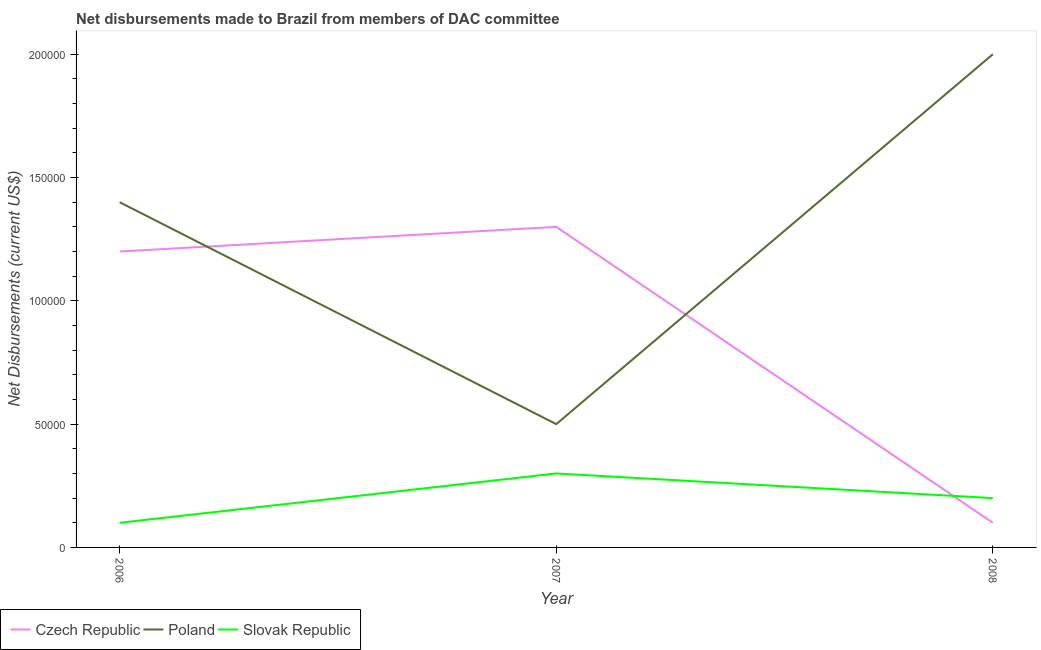Is the number of lines equal to the number of legend labels?
Make the answer very short. Yes. What is the net disbursements made by slovak republic in 2006?
Provide a succinct answer. 10000. Across all years, what is the maximum net disbursements made by poland?
Your answer should be very brief. 2.00e+05. Across all years, what is the minimum net disbursements made by poland?
Your answer should be compact. 5.00e+04. What is the total net disbursements made by czech republic in the graph?
Your response must be concise. 2.60e+05. What is the difference between the net disbursements made by slovak republic in 2006 and that in 2007?
Your answer should be compact. -2.00e+04. What is the difference between the net disbursements made by poland in 2008 and the net disbursements made by czech republic in 2007?
Provide a succinct answer. 7.00e+04. What is the average net disbursements made by czech republic per year?
Provide a succinct answer. 8.67e+04. In the year 2008, what is the difference between the net disbursements made by czech republic and net disbursements made by poland?
Provide a short and direct response. -1.90e+05. In how many years, is the net disbursements made by czech republic greater than 20000 US$?
Give a very brief answer. 2. Is the net disbursements made by poland in 2006 less than that in 2007?
Keep it short and to the point. No. What is the difference between the highest and the lowest net disbursements made by czech republic?
Your answer should be very brief. 1.20e+05. In how many years, is the net disbursements made by slovak republic greater than the average net disbursements made by slovak republic taken over all years?
Give a very brief answer. 1. Is the sum of the net disbursements made by poland in 2007 and 2008 greater than the maximum net disbursements made by slovak republic across all years?
Your answer should be compact. Yes. Is it the case that in every year, the sum of the net disbursements made by czech republic and net disbursements made by poland is greater than the net disbursements made by slovak republic?
Keep it short and to the point. Yes. How many lines are there?
Your response must be concise. 3. What is the difference between two consecutive major ticks on the Y-axis?
Keep it short and to the point. 5.00e+04. How many legend labels are there?
Make the answer very short. 3. How are the legend labels stacked?
Keep it short and to the point. Horizontal. What is the title of the graph?
Make the answer very short. Net disbursements made to Brazil from members of DAC committee. Does "Capital account" appear as one of the legend labels in the graph?
Ensure brevity in your answer.  No. What is the label or title of the X-axis?
Make the answer very short. Year. What is the label or title of the Y-axis?
Your answer should be very brief. Net Disbursements (current US$). What is the Net Disbursements (current US$) of Czech Republic in 2006?
Give a very brief answer. 1.20e+05. What is the Net Disbursements (current US$) of Czech Republic in 2007?
Keep it short and to the point. 1.30e+05. What is the Net Disbursements (current US$) of Slovak Republic in 2007?
Provide a succinct answer. 3.00e+04. What is the Net Disbursements (current US$) of Czech Republic in 2008?
Make the answer very short. 10000. What is the Net Disbursements (current US$) of Poland in 2008?
Your answer should be compact. 2.00e+05. Across all years, what is the maximum Net Disbursements (current US$) of Czech Republic?
Offer a terse response. 1.30e+05. Across all years, what is the maximum Net Disbursements (current US$) of Poland?
Provide a short and direct response. 2.00e+05. Across all years, what is the maximum Net Disbursements (current US$) of Slovak Republic?
Your answer should be compact. 3.00e+04. What is the difference between the Net Disbursements (current US$) of Czech Republic in 2006 and that in 2007?
Offer a terse response. -10000. What is the difference between the Net Disbursements (current US$) of Poland in 2006 and that in 2007?
Give a very brief answer. 9.00e+04. What is the difference between the Net Disbursements (current US$) in Slovak Republic in 2006 and that in 2007?
Provide a succinct answer. -2.00e+04. What is the difference between the Net Disbursements (current US$) in Poland in 2006 and that in 2008?
Your answer should be compact. -6.00e+04. What is the difference between the Net Disbursements (current US$) of Slovak Republic in 2006 and that in 2008?
Your answer should be compact. -10000. What is the difference between the Net Disbursements (current US$) of Czech Republic in 2007 and that in 2008?
Provide a succinct answer. 1.20e+05. What is the difference between the Net Disbursements (current US$) of Poland in 2007 and that in 2008?
Offer a terse response. -1.50e+05. What is the difference between the Net Disbursements (current US$) in Slovak Republic in 2007 and that in 2008?
Your response must be concise. 10000. What is the difference between the Net Disbursements (current US$) in Czech Republic in 2006 and the Net Disbursements (current US$) in Slovak Republic in 2007?
Your response must be concise. 9.00e+04. What is the difference between the Net Disbursements (current US$) in Poland in 2006 and the Net Disbursements (current US$) in Slovak Republic in 2007?
Offer a terse response. 1.10e+05. What is the difference between the Net Disbursements (current US$) in Czech Republic in 2006 and the Net Disbursements (current US$) in Poland in 2008?
Your response must be concise. -8.00e+04. What is the difference between the Net Disbursements (current US$) of Czech Republic in 2007 and the Net Disbursements (current US$) of Slovak Republic in 2008?
Provide a short and direct response. 1.10e+05. What is the difference between the Net Disbursements (current US$) of Poland in 2007 and the Net Disbursements (current US$) of Slovak Republic in 2008?
Offer a terse response. 3.00e+04. What is the average Net Disbursements (current US$) in Czech Republic per year?
Provide a short and direct response. 8.67e+04. What is the average Net Disbursements (current US$) in Poland per year?
Your answer should be compact. 1.30e+05. In the year 2006, what is the difference between the Net Disbursements (current US$) in Czech Republic and Net Disbursements (current US$) in Poland?
Your answer should be compact. -2.00e+04. In the year 2007, what is the difference between the Net Disbursements (current US$) in Czech Republic and Net Disbursements (current US$) in Slovak Republic?
Give a very brief answer. 1.00e+05. In the year 2007, what is the difference between the Net Disbursements (current US$) in Poland and Net Disbursements (current US$) in Slovak Republic?
Offer a terse response. 2.00e+04. In the year 2008, what is the difference between the Net Disbursements (current US$) of Poland and Net Disbursements (current US$) of Slovak Republic?
Keep it short and to the point. 1.80e+05. What is the ratio of the Net Disbursements (current US$) in Poland in 2006 to that in 2007?
Provide a short and direct response. 2.8. What is the ratio of the Net Disbursements (current US$) of Poland in 2006 to that in 2008?
Offer a very short reply. 0.7. What is the ratio of the Net Disbursements (current US$) in Czech Republic in 2007 to that in 2008?
Make the answer very short. 13. What is the ratio of the Net Disbursements (current US$) of Poland in 2007 to that in 2008?
Ensure brevity in your answer.  0.25. What is the ratio of the Net Disbursements (current US$) in Slovak Republic in 2007 to that in 2008?
Your response must be concise. 1.5. What is the difference between the highest and the second highest Net Disbursements (current US$) of Czech Republic?
Ensure brevity in your answer.  10000. What is the difference between the highest and the second highest Net Disbursements (current US$) in Slovak Republic?
Provide a short and direct response. 10000. What is the difference between the highest and the lowest Net Disbursements (current US$) of Poland?
Ensure brevity in your answer.  1.50e+05. What is the difference between the highest and the lowest Net Disbursements (current US$) in Slovak Republic?
Provide a short and direct response. 2.00e+04. 